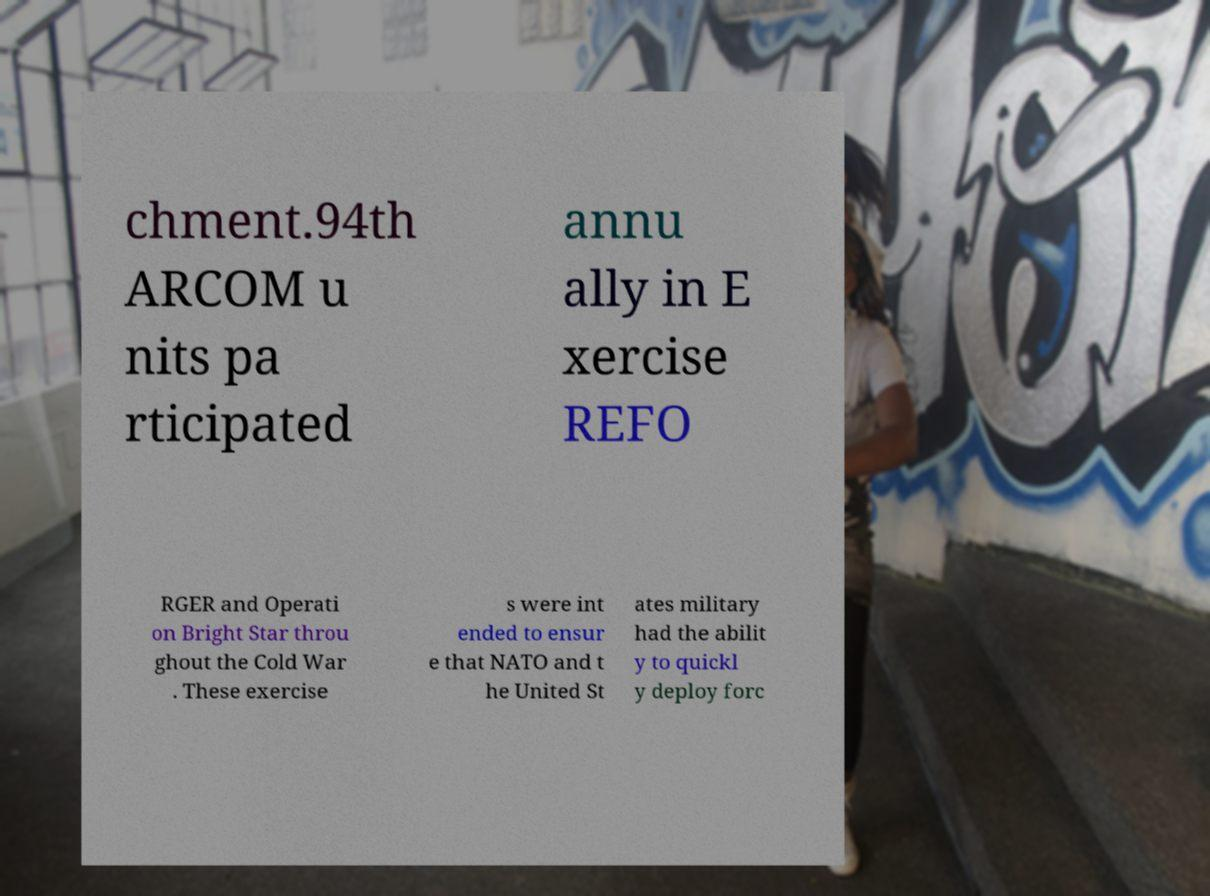Please identify and transcribe the text found in this image. chment.94th ARCOM u nits pa rticipated annu ally in E xercise REFO RGER and Operati on Bright Star throu ghout the Cold War . These exercise s were int ended to ensur e that NATO and t he United St ates military had the abilit y to quickl y deploy forc 